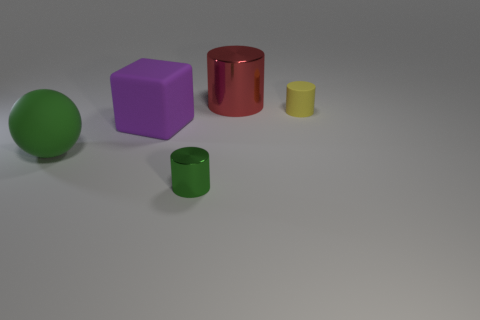Subtract all red cylinders. How many cylinders are left? 2 Subtract all metal cylinders. How many cylinders are left? 1 Subtract all blocks. How many objects are left? 4 Subtract all red cubes. How many purple cylinders are left? 0 Add 4 brown cubes. How many brown cubes exist? 4 Add 4 tiny yellow cylinders. How many objects exist? 9 Subtract 1 yellow cylinders. How many objects are left? 4 Subtract all brown spheres. Subtract all yellow blocks. How many spheres are left? 1 Subtract all yellow matte objects. Subtract all green matte balls. How many objects are left? 3 Add 1 big blocks. How many big blocks are left? 2 